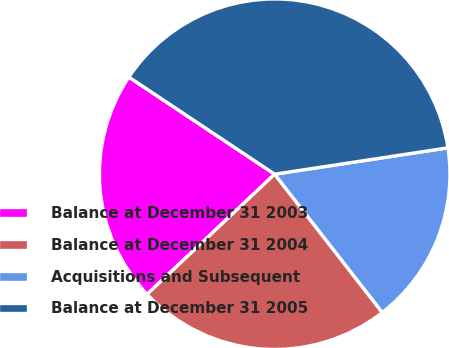<chart> <loc_0><loc_0><loc_500><loc_500><pie_chart><fcel>Balance at December 31 2003<fcel>Balance at December 31 2004<fcel>Acquisitions and Subsequent<fcel>Balance at December 31 2005<nl><fcel>21.37%<fcel>23.51%<fcel>16.88%<fcel>38.25%<nl></chart> 